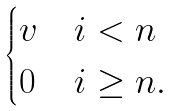Convert formula to latex. <formula><loc_0><loc_0><loc_500><loc_500>\begin{cases} v & i < n \\ 0 & i \geq n . \end{cases}</formula> 